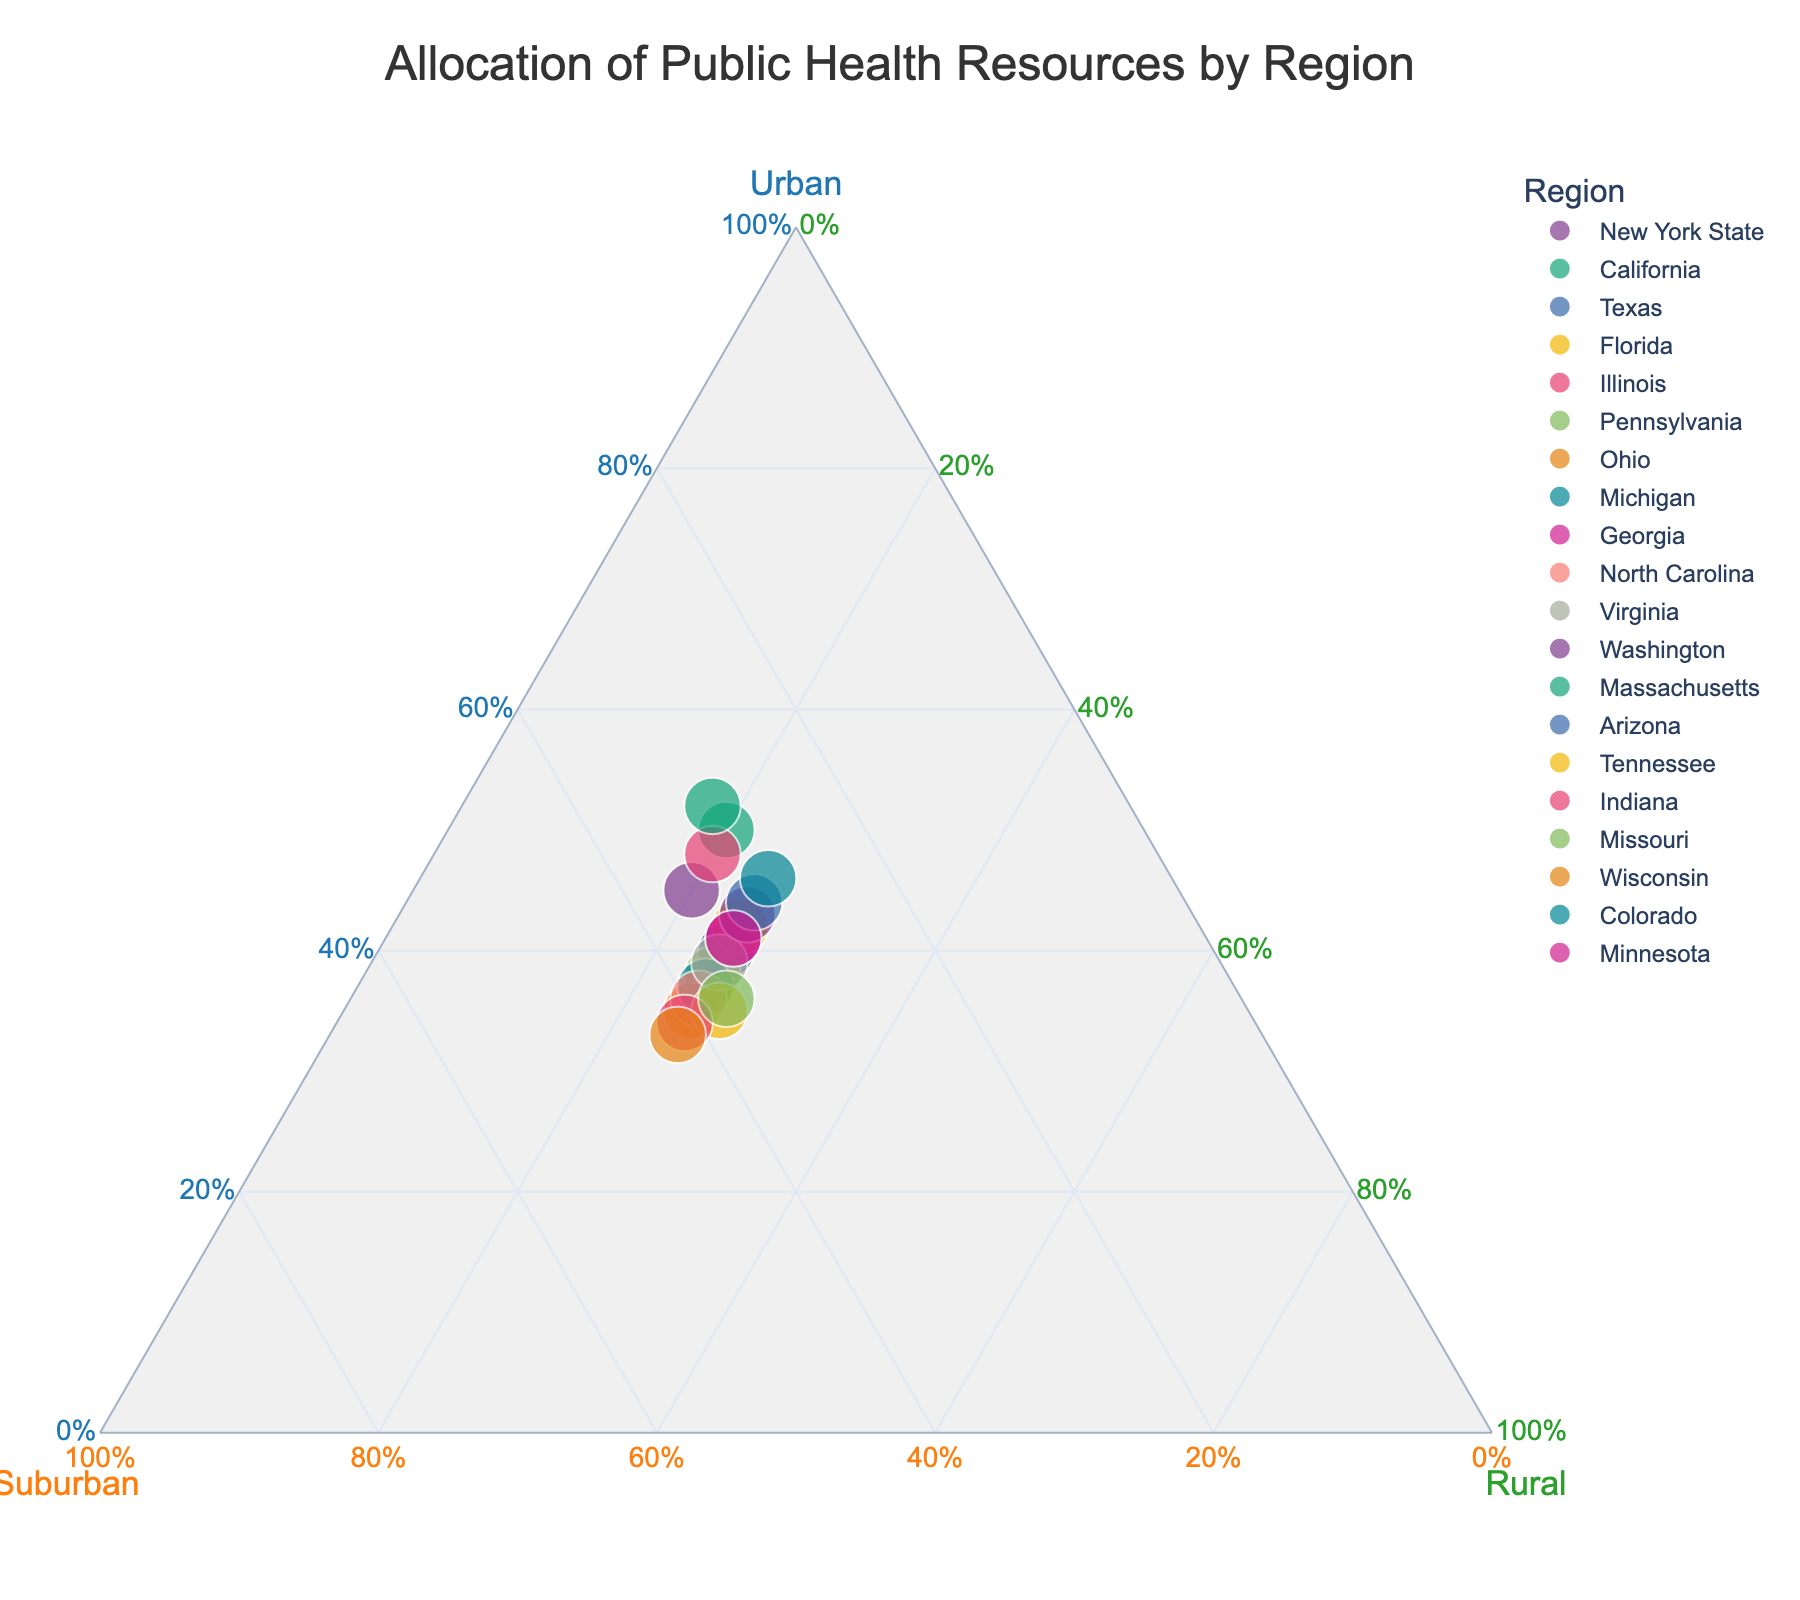What is the title of the plot? The title is displayed at the top center of the plot. It visually indicates the main subject or focus of the plot.
Answer: Allocation of Public Health Resources by Region Which region has the highest allocation of resources to the urban area? Look at the point closest to the "Urban" axis title's vertex. The region associated with that point is the one with the highest urban resource allocation.
Answer: Massachusetts What is the proportion of suburban area allocation for Ohio? Find the point representing Ohio and observe its position relative to the "Suburban" axis. The hover template will also display this information when you hover over the point.
Answer: 40% How do the urban resource allocations compare between New York State and California? Identify the points for New York State and California. The position closer to the "Urban" title's vertex indicates higher urban allocation. Compare their distances.
Answer: New York State: 45%, California: 50% Which region allocates 20% of its resources to rural areas? Find points along the line segment associated with the 20% mark on the "Rural" axis. Check the hover template for regions corresponding to these points.
Answer: California, Illinois, and New York State On average, how much percentage is allocated to rural areas across all the regions in the plot? Identify the percentages for rural allocation for all regions, sum them up, and divide by the number of regions to find the average. [(20+20+25+25+20+25+25+25+25+25+25+25+18+25+27+25+27+25+25+25) ÷ 20]
Answer: 24% Between Texas and Florida, which region allocates higher resources to suburban areas? Locate the points for Texas and Florida. The position closer to the "Suburban" title's vertex indicates higher suburban allocation. Compare their distances.
Answer: Texas: 35%, Florida: 33% How many regions allocate more than 40% of resources to urban areas? Identify and count the points positioned closer to the "Urban" vertex than the 40% mark, using their hover templates to verify urban allocation.
Answer: 8 regions What is the difference in resource allocation to rural areas between Pennsylvania and Indiana? Locate the points for Pennsylvania and Indiana and observe their proximity to the "Rural" vertex. Subtract one rural allocation percentage from the other.
Answer: 0% Which region has the highest allocation of resources to suburban areas? Observe points closest to the "Suburban" vertex. The region related to the nearest point is the highest suburban resource allocator.
Answer: Wisconsin 